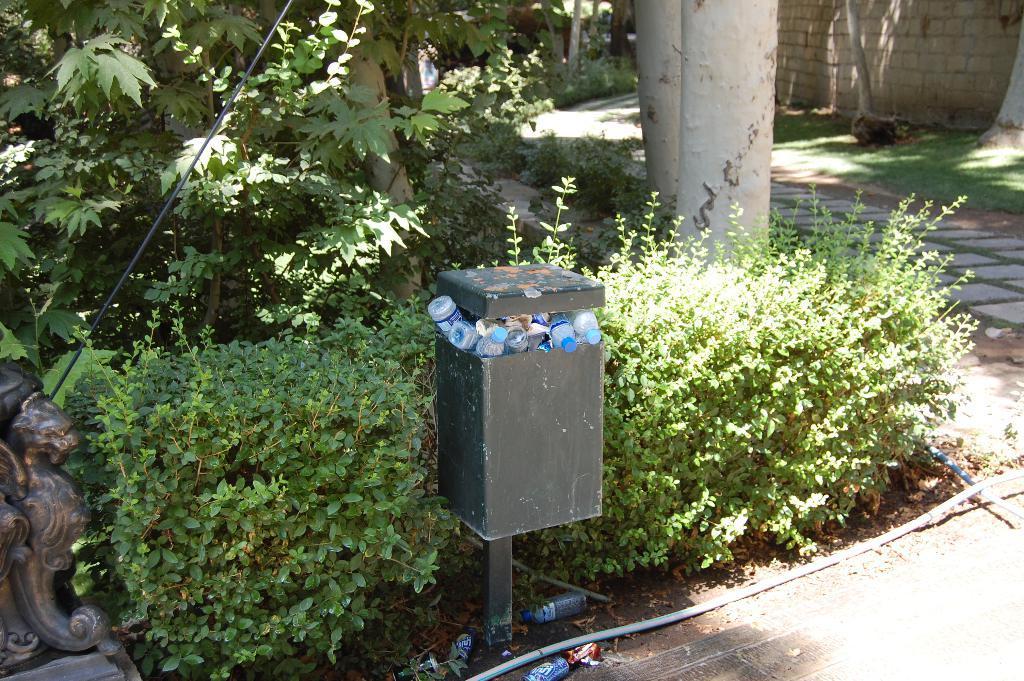How would you summarize this image in a sentence or two? In the middle of the picture, we see a garbage bin containing many water bottles. Behind that, we see the shrubs. Behind that, we see the white poles. In the left bottom, it looks like a pillar with a lion shaped statue. In the background, we see the trees. In the right top, we see the grass and a wall. At the bottom, we see the pavement, white pipe and water bottles. 